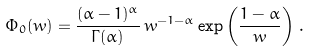<formula> <loc_0><loc_0><loc_500><loc_500>\Phi _ { 0 } ( w ) = \frac { ( \alpha - 1 ) ^ { \alpha } } { \Gamma ( \alpha ) } \, w ^ { - 1 - \alpha } \exp \left ( \frac { 1 - \alpha } { w } \right ) \, .</formula> 